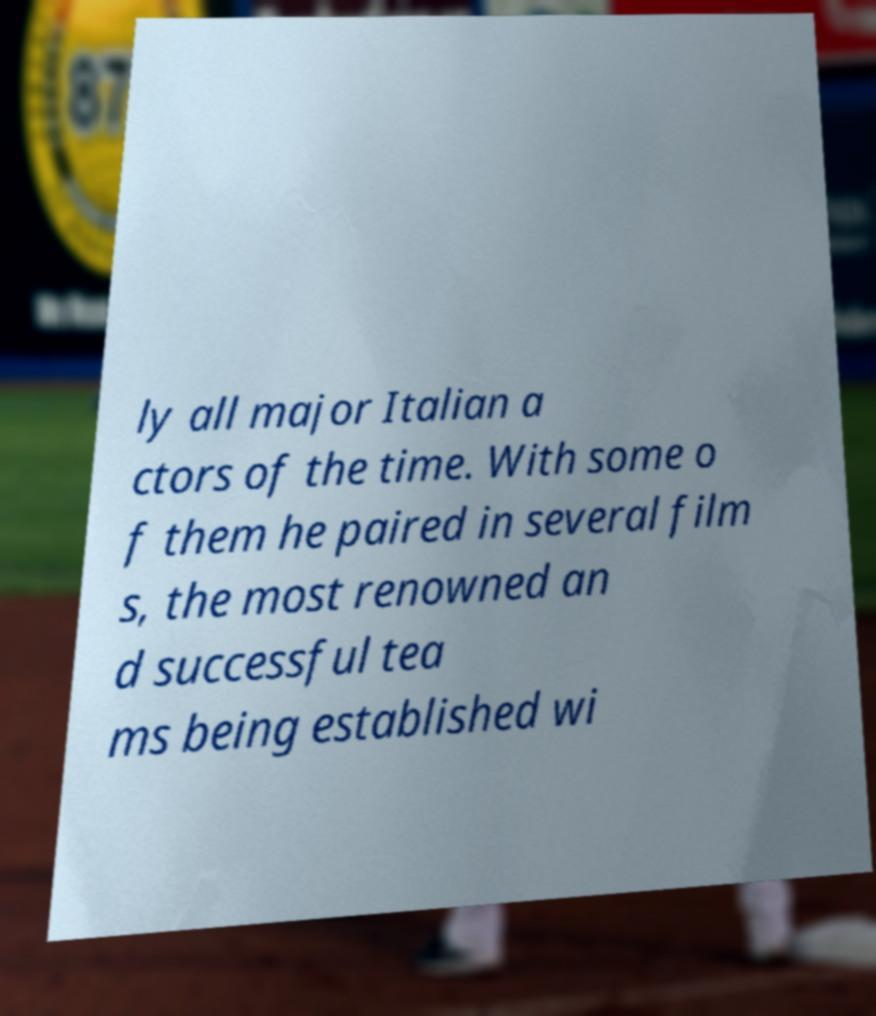For documentation purposes, I need the text within this image transcribed. Could you provide that? ly all major Italian a ctors of the time. With some o f them he paired in several film s, the most renowned an d successful tea ms being established wi 